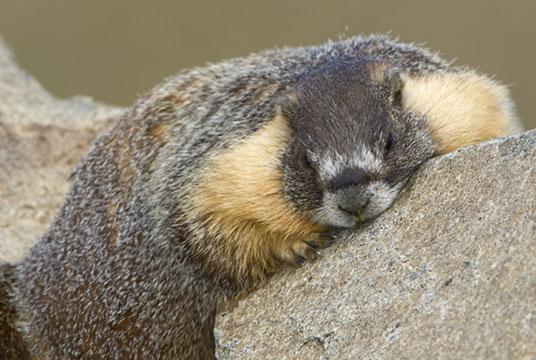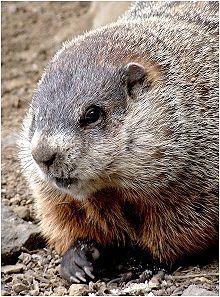The first image is the image on the left, the second image is the image on the right. Evaluate the accuracy of this statement regarding the images: "The animals in both images face approximately the same direction.". Is it true? Answer yes or no. No. 